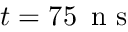<formula> <loc_0><loc_0><loc_500><loc_500>t = 7 5 \, n s</formula> 